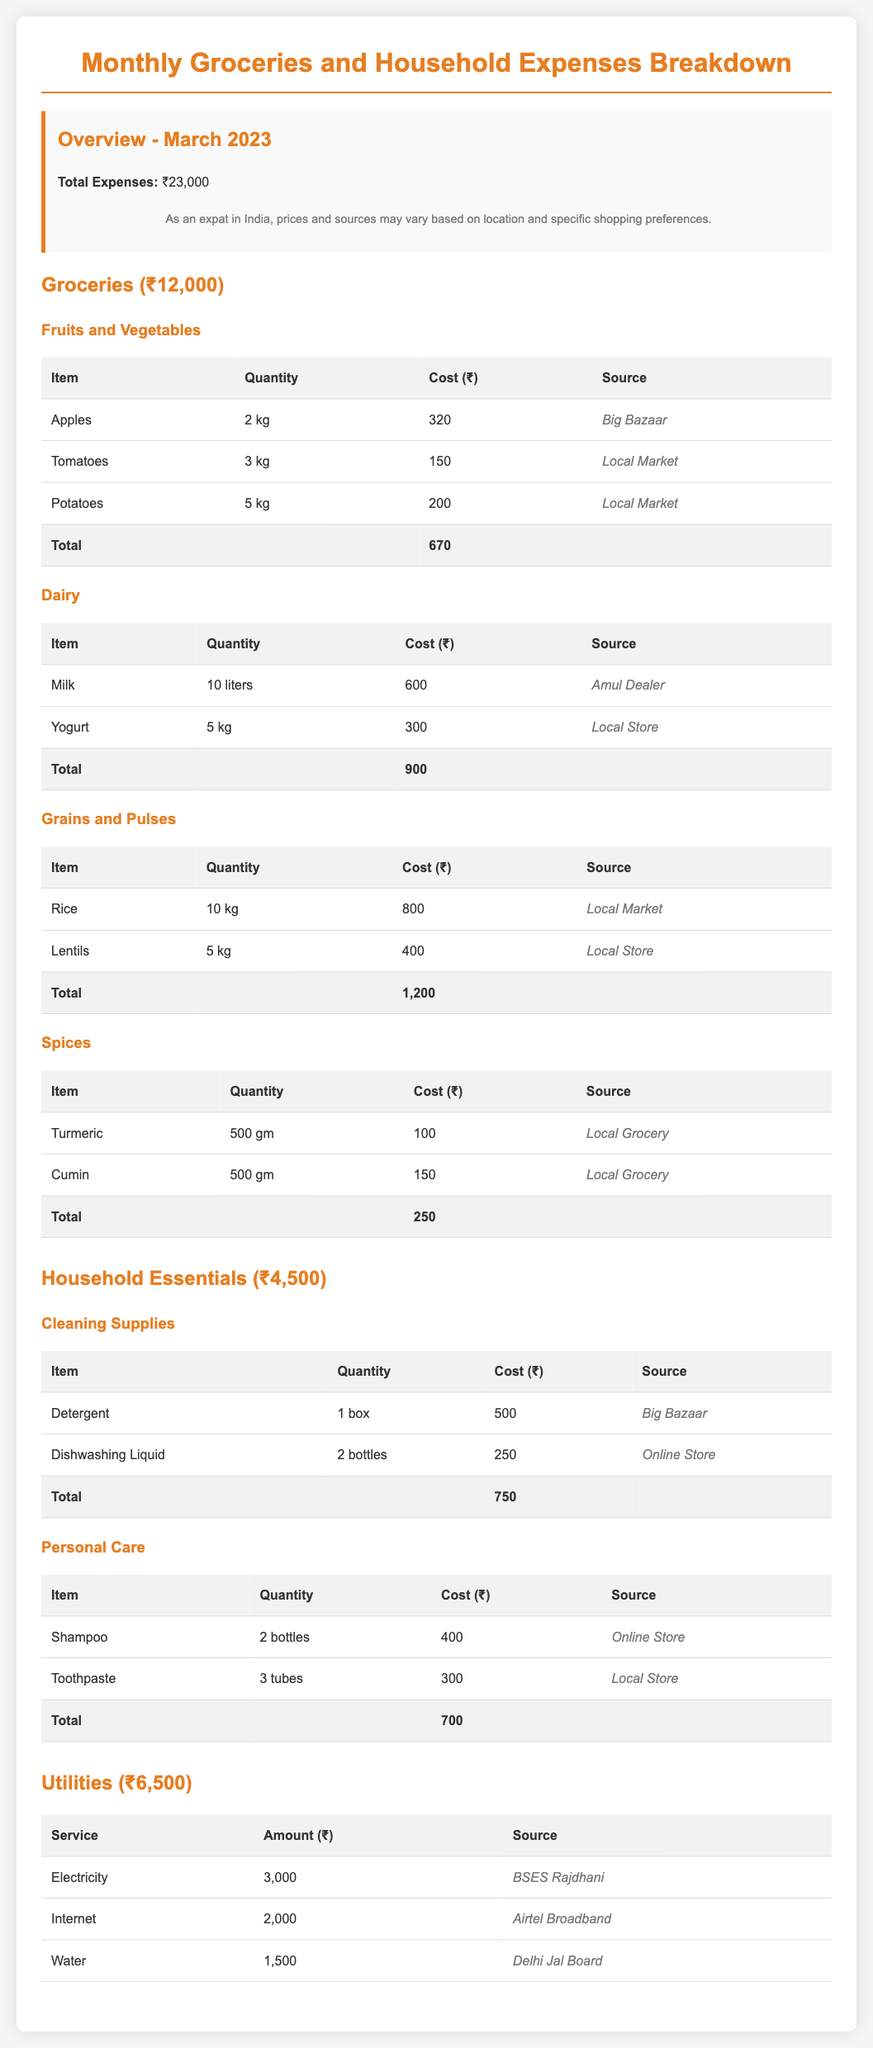what is the total expense for March 2023? The total expense is mentioned in the overview section, which states that the total expenses for March 2023 are ₹23,000.
Answer: ₹23,000 how much was spent on groceries? The total spent on groceries is found in the section that details grocery expenses, which totals ₹12,000.
Answer: ₹12,000 what is the cost of milk per liter? The cost of milk is reported as ₹600 for 10 liters, which means it costs ₹60 per liter.
Answer: ₹60 how many kilograms of potatoes were purchased? The quantity of potatoes is specified in the fruits and vegetables section, indicating 5 kg were purchased.
Answer: 5 kg which source provided the highest grocery cost? The highest source mentioned for grocery costs is the 'Local Market', which indicates it provided goods for more than one category totaling ₹1,350 (Potatoes, Rice, and Tomatoes).
Answer: Local Market what is the total cost for personal care items? The personal care items are totaled under the household essentials category at ₹700.
Answer: ₹700 how much was spent on cleaning supplies? The cleaning supplies total is clearly listed in the cleaning supplies section, which is ₹750.
Answer: ₹750 who is the provider for electricity services? The document states that the provider for electricity services is BSES Rajdhani.
Answer: BSES Rajdhani what percentage of the total expenses were for utilities? Utilities amount to ₹6,500; thus, the percentage of total expenses that were for utilities can be calculated as (₹6,500/₹23,000)*100, which is approximately 28.26%.
Answer: 28.26% 